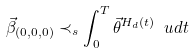Convert formula to latex. <formula><loc_0><loc_0><loc_500><loc_500>\vec { \beta } _ { ( 0 , 0 , 0 ) } \prec _ { s } \int _ { 0 } ^ { T } \vec { \theta } ^ { H _ { d } ( t ) } \ u d t</formula> 